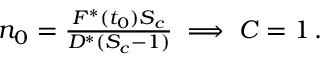<formula> <loc_0><loc_0><loc_500><loc_500>\begin{array} { r } { n _ { 0 } = \frac { F ^ { * } ( t _ { 0 } ) S _ { c } } { D ^ { * } ( S _ { c } - 1 ) } \implies C = 1 \, . } \end{array}</formula> 